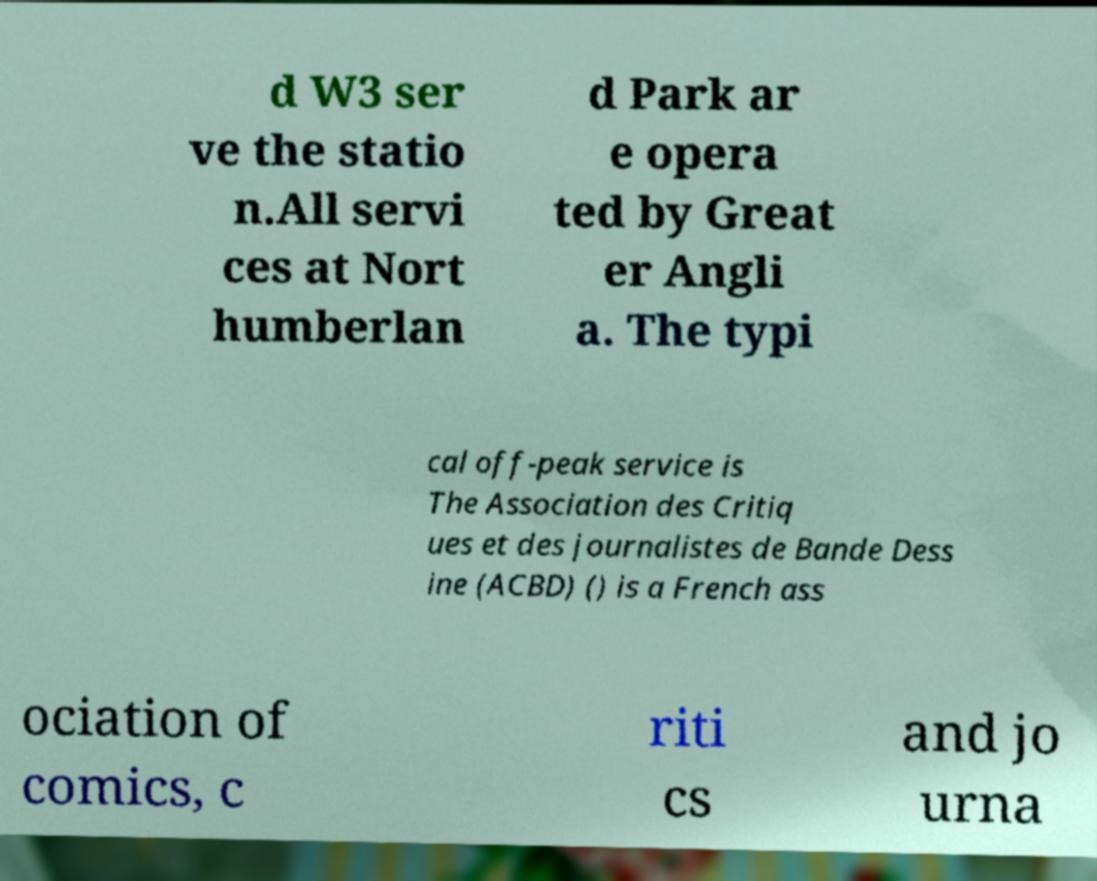Can you read and provide the text displayed in the image?This photo seems to have some interesting text. Can you extract and type it out for me? d W3 ser ve the statio n.All servi ces at Nort humberlan d Park ar e opera ted by Great er Angli a. The typi cal off-peak service is The Association des Critiq ues et des journalistes de Bande Dess ine (ACBD) () is a French ass ociation of comics, c riti cs and jo urna 